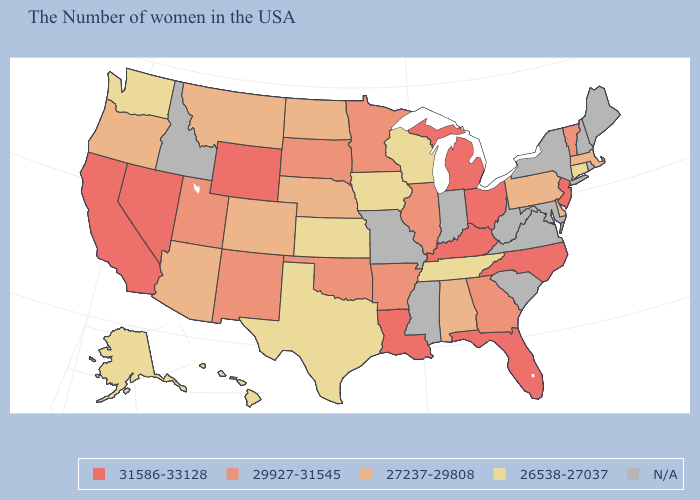Name the states that have a value in the range 29927-31545?
Write a very short answer. Vermont, Georgia, Illinois, Arkansas, Minnesota, Oklahoma, South Dakota, New Mexico, Utah. Name the states that have a value in the range 26538-27037?
Write a very short answer. Connecticut, Tennessee, Wisconsin, Iowa, Kansas, Texas, Washington, Alaska, Hawaii. What is the value of Alaska?
Quick response, please. 26538-27037. What is the lowest value in the USA?
Give a very brief answer. 26538-27037. What is the value of Rhode Island?
Quick response, please. N/A. Name the states that have a value in the range 26538-27037?
Keep it brief. Connecticut, Tennessee, Wisconsin, Iowa, Kansas, Texas, Washington, Alaska, Hawaii. What is the value of Montana?
Short answer required. 27237-29808. Among the states that border Tennessee , does Alabama have the highest value?
Keep it brief. No. Which states have the lowest value in the USA?
Quick response, please. Connecticut, Tennessee, Wisconsin, Iowa, Kansas, Texas, Washington, Alaska, Hawaii. What is the value of Arkansas?
Be succinct. 29927-31545. What is the value of Alaska?
Short answer required. 26538-27037. What is the value of Maine?
Quick response, please. N/A. Name the states that have a value in the range N/A?
Concise answer only. Maine, Rhode Island, New Hampshire, New York, Maryland, Virginia, South Carolina, West Virginia, Indiana, Mississippi, Missouri, Idaho. 